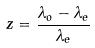Convert formula to latex. <formula><loc_0><loc_0><loc_500><loc_500>z = \frac { \lambda _ { o } - \lambda _ { e } } { \lambda _ { e } }</formula> 